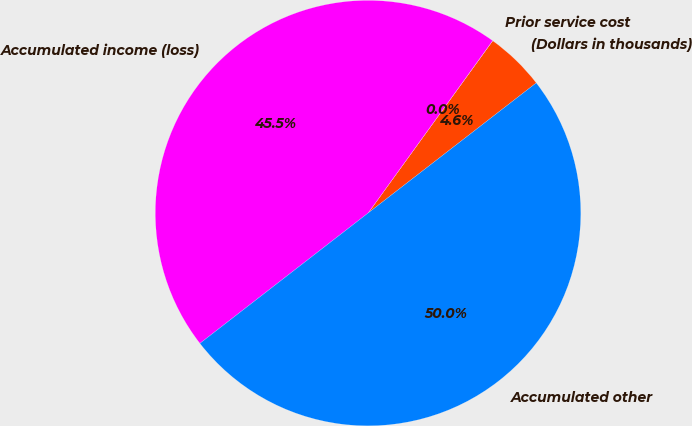<chart> <loc_0><loc_0><loc_500><loc_500><pie_chart><fcel>(Dollars in thousands)<fcel>Prior service cost<fcel>Accumulated income (loss)<fcel>Accumulated other<nl><fcel>4.55%<fcel>0.01%<fcel>45.45%<fcel>49.99%<nl></chart> 